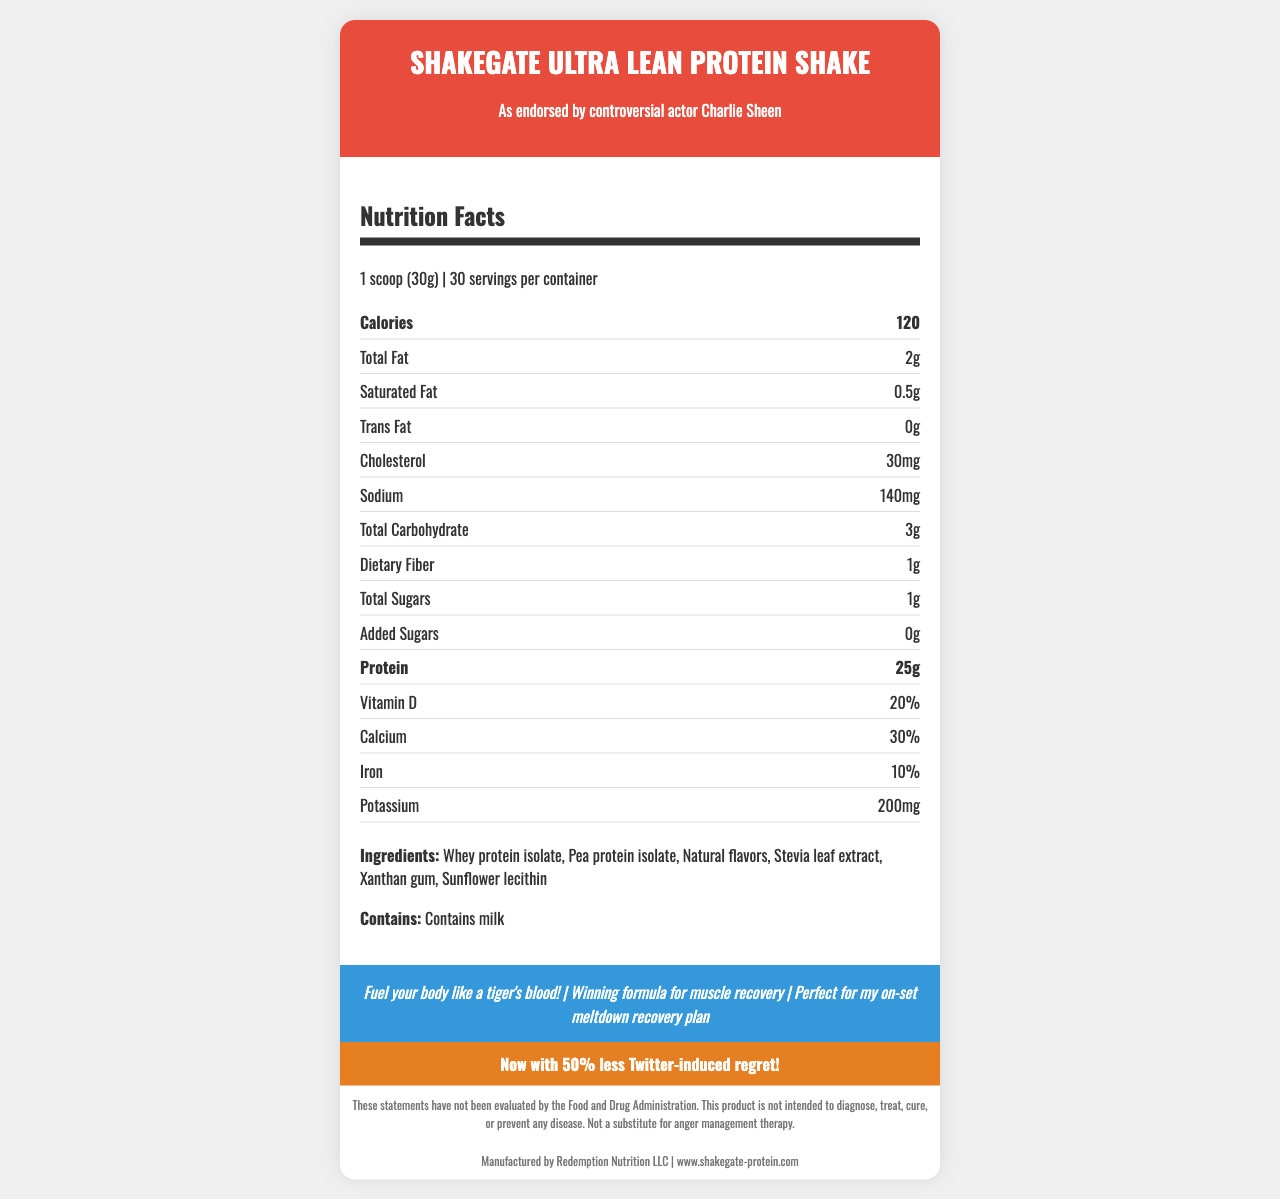What is the serving size of the ShakeGate Ultra Lean Protein Shake? The document specifies the serving size as "1 scoop (30g)" in the Nutrition Facts section.
Answer: 1 scoop (30g) How many servings are there in one container of the shake? The document states that there are 30 servings per container.
Answer: 30 How many grams of protein are in a single serving? According to the Nutrition Facts, a single serving contains 25 grams of protein.
Answer: 25g What is the total carbohydrate content per serving? The Nutrition Facts list the total carbohydrate content as 3 grams per serving.
Answer: 3g What allergens are present in the shake? The document lists "Contains milk" under the allergens section.
Answer: Contains milk How many calories are in one serving of the shake?
A. 100
B. 120
C. 150
D. 200 The Nutrition Facts section indicates that each serving has 120 calories.
Answer: B Which ingredient is listed first?
A. Xanthan gum
B. Whey protein isolate
C. Stevia leaf extract
D. Pea protein isolate The ingredients are listed in the order: "Whey protein isolate, Pea protein isolate, Natural flavors, Stevia leaf extract, Xanthan gum, Sunflower lecithin".
Answer: B Is the shake intended as a substitute for anger management therapy? The disclaimer explicitly states, "Not a substitute for anger management therapy."
Answer: No What is the main idea of the document? The document is a detailed description about the ShakeGate Ultra Lean Protein Shake, covering aspects like nutritional content, ingredients, allergens, marketing claims by the actor Charlie Sheen, and a disclaimer about product claims.
Answer: The main idea of the document is to present the nutrition facts and other relevant information for the ShakeGate Ultra Lean Protein Shake, a high-protein, low-carb meal replacement endorsed by the controversial actor Charlie Sheen. It includes details on serving size, nutritional content, ingredients, allergens, marketing claims, and a disclaimer. What is the retail price of the ShakeGate Ultra Lean Protein Shake? The document does not provide any information about the retail price of the product.
Answer: Cannot be determined 